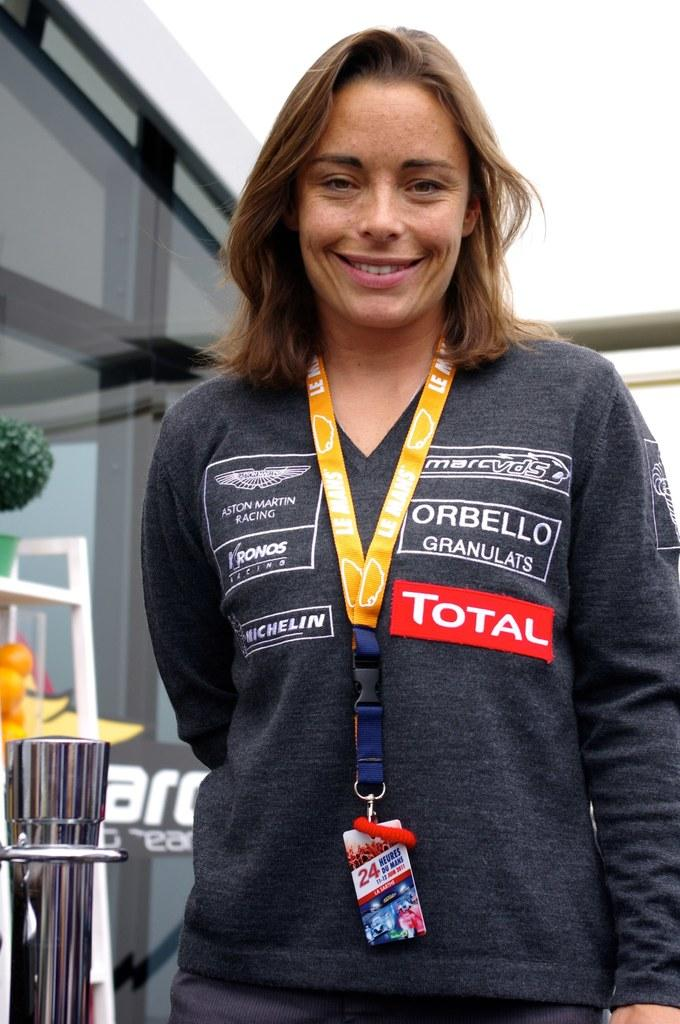<image>
Relay a brief, clear account of the picture shown. A woman is standing for the photo and has a red tag that says total on her gray shirt. 